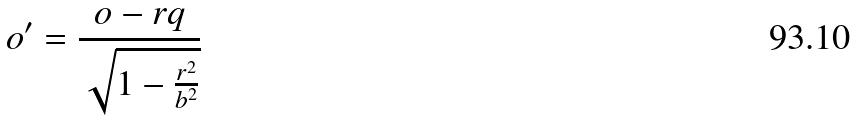Convert formula to latex. <formula><loc_0><loc_0><loc_500><loc_500>o ^ { \prime } = \frac { o - r q } { \sqrt { 1 - \frac { r ^ { 2 } } { b ^ { 2 } } } }</formula> 